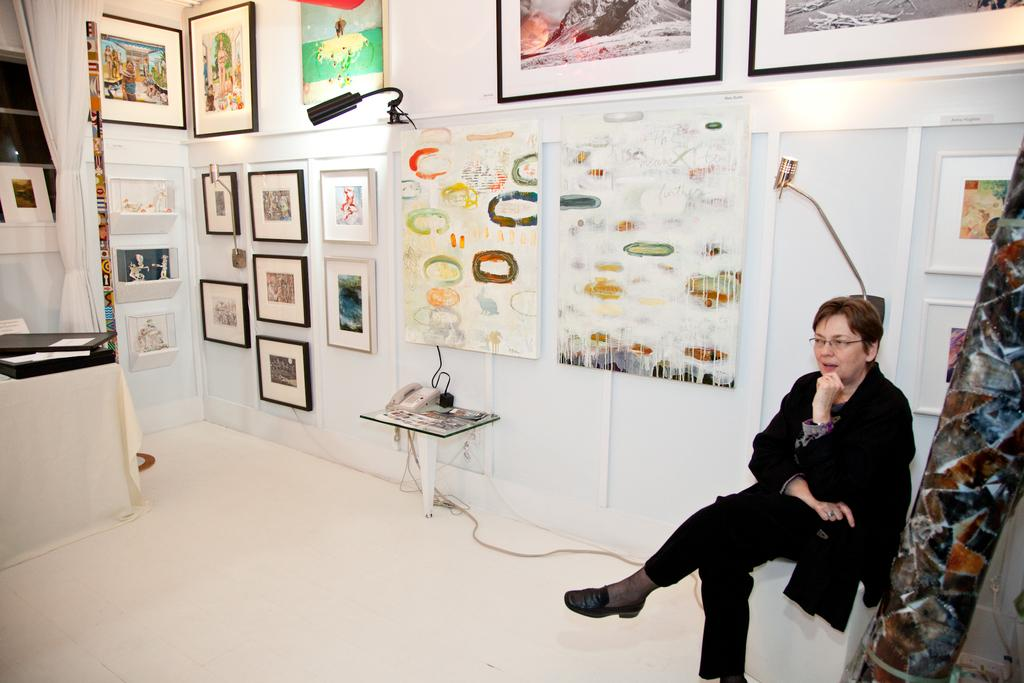What can be seen hanging on the wall in the image? There are photo frames on the wall in the image. What is the woman in the image doing? The woman is seated in the image. What color is the dress the woman is wearing? The woman is wearing a black dress. What object is on the table in the image? There is a telephone on a table in the image. What type of window treatment is present in the image? There is a curtain in the image. Can you see any bones in the image? There are no bones present in the image. What type of bird can be seen flying in the image? There are no birds present in the image. 